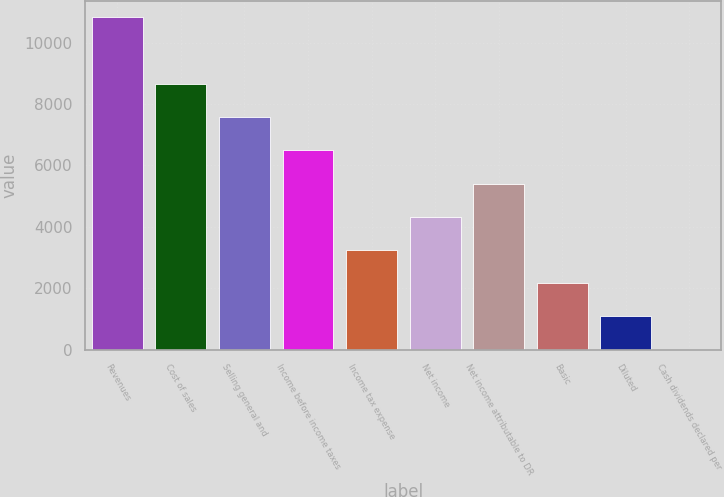Convert chart. <chart><loc_0><loc_0><loc_500><loc_500><bar_chart><fcel>Revenues<fcel>Cost of sales<fcel>Selling general and<fcel>Income before income taxes<fcel>Income tax expense<fcel>Net income<fcel>Net income attributable to DR<fcel>Basic<fcel>Diluted<fcel>Cash dividends declared per<nl><fcel>10824<fcel>8659.23<fcel>7576.85<fcel>6494.48<fcel>3247.36<fcel>4329.74<fcel>5412.11<fcel>2164.99<fcel>1082.62<fcel>0.25<nl></chart> 